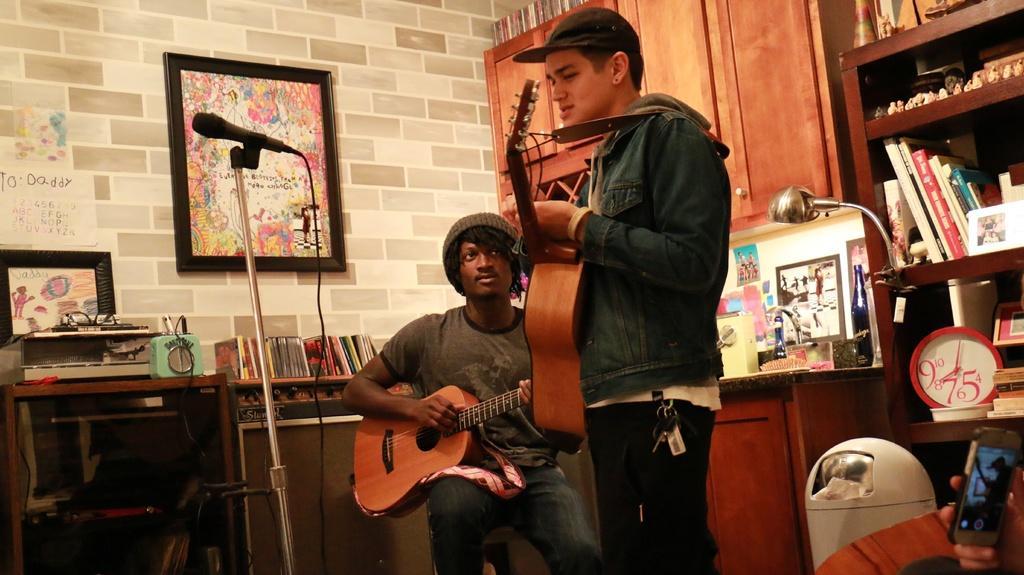Could you give a brief overview of what you see in this image? In this image i can see two men playing the guitar, in front of the men there is a microphone at the back there is a brick wall and a frame attached to it. Beside a wall there is wooden shelf some books contained in it there is lamp and the clock on the table. I can see the spectacles on the machine. 